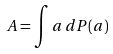Convert formula to latex. <formula><loc_0><loc_0><loc_500><loc_500>A = \int a \, d P ( a )</formula> 